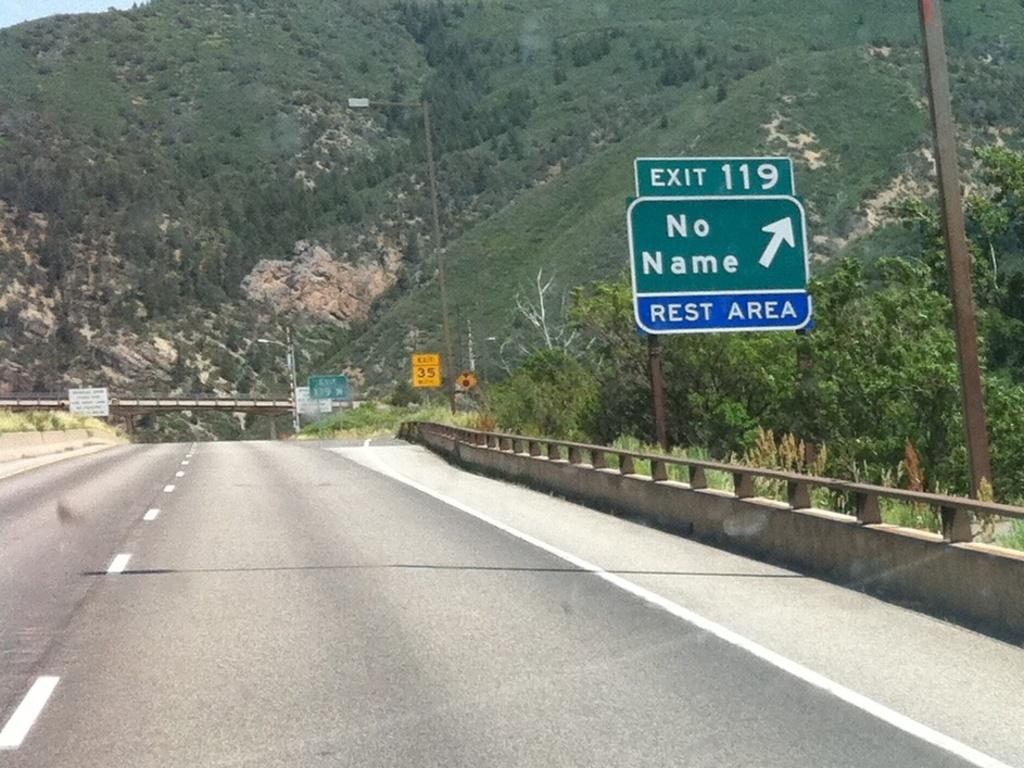What is the main feature of the image? There is a road in the image. What else can be seen on the road? There is a board with writing on it in the image. Where is the board located in the image? The board is attached to a pole in the right corner of the image. What can be seen in the background of the image? There are trees and mountains in the background of the image. What type of shoe is being served for dinner in the image? There is no shoe or dinner present in the image; it features a road, a board with writing, and a background with trees and mountains. 